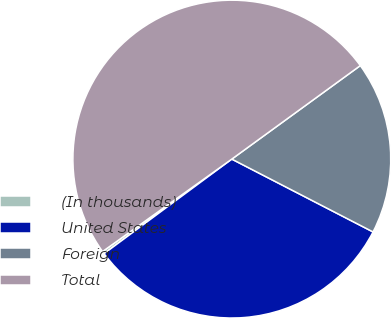<chart> <loc_0><loc_0><loc_500><loc_500><pie_chart><fcel>(In thousands)<fcel>United States<fcel>Foreign<fcel>Total<nl><fcel>0.26%<fcel>32.28%<fcel>17.59%<fcel>49.87%<nl></chart> 